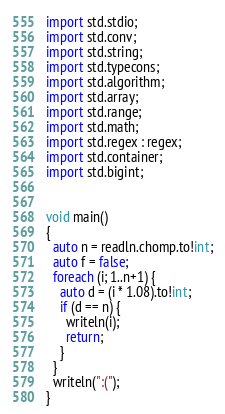Convert code to text. <code><loc_0><loc_0><loc_500><loc_500><_D_>import std.stdio;
import std.conv;
import std.string;
import std.typecons;
import std.algorithm;
import std.array;
import std.range;
import std.math;
import std.regex : regex;
import std.container;
import std.bigint;


void main()
{
  auto n = readln.chomp.to!int;
  auto f = false;
  foreach (i; 1..n+1) {
    auto d = (i * 1.08).to!int;
    if (d == n) {
      writeln(i);
      return;
    }
  }
  writeln(":(");
}
</code> 